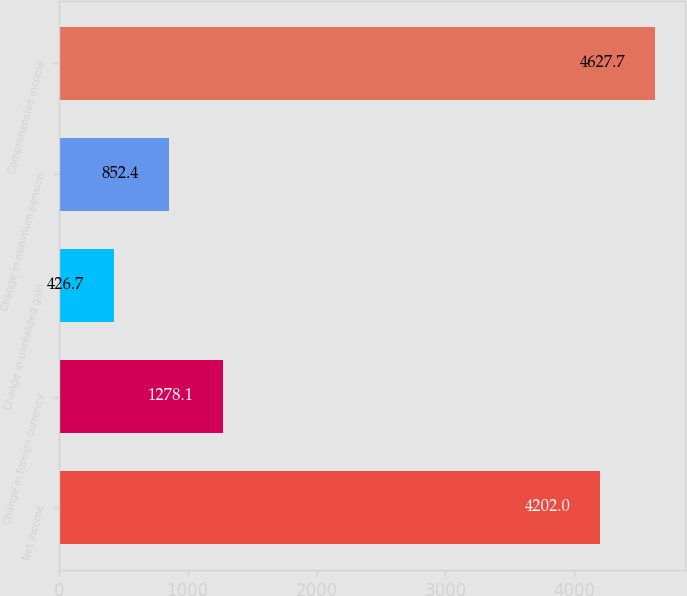<chart> <loc_0><loc_0><loc_500><loc_500><bar_chart><fcel>Net income<fcel>Change in foreign currency<fcel>Change in unrealized gain<fcel>Change in minimum pension<fcel>Comprehensive income<nl><fcel>4202<fcel>1278.1<fcel>426.7<fcel>852.4<fcel>4627.7<nl></chart> 